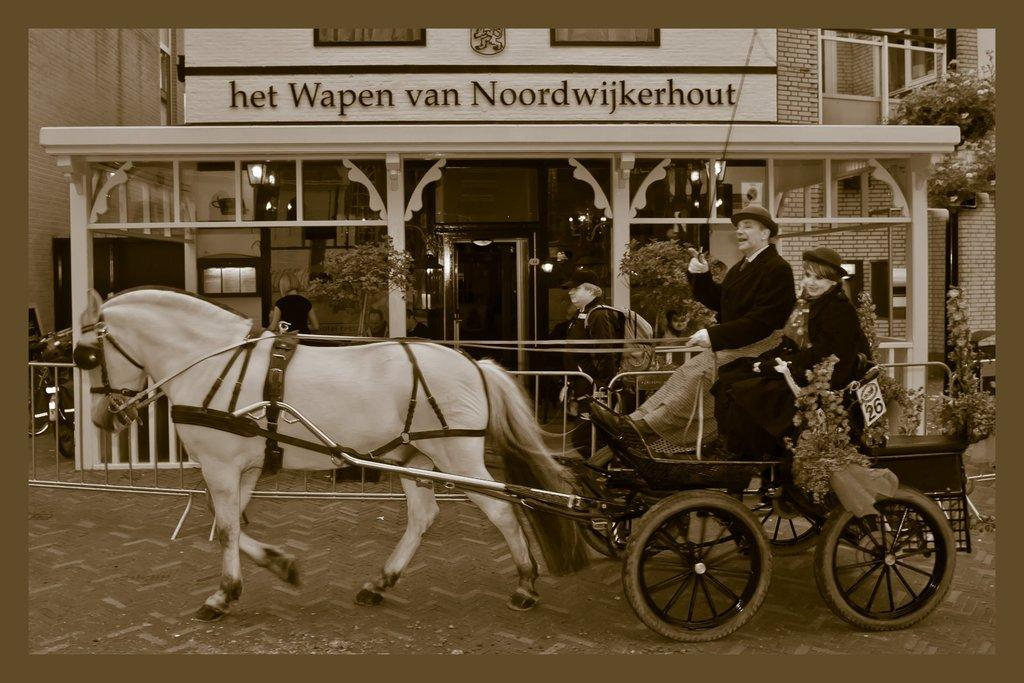What mode of transportation is featured in the image? There is a horse cart in the image. How many people are using the horse cart? Two people are sitting in the horse cart. What can be seen in the background of the image? There is a huge building in the background of the image. What color scheme is used in the image? The image is in black and white color. Can you tell me how many goldfish are swimming in the horse cart? There are no goldfish present in the image; it features a horse cart with two people sitting in it. 